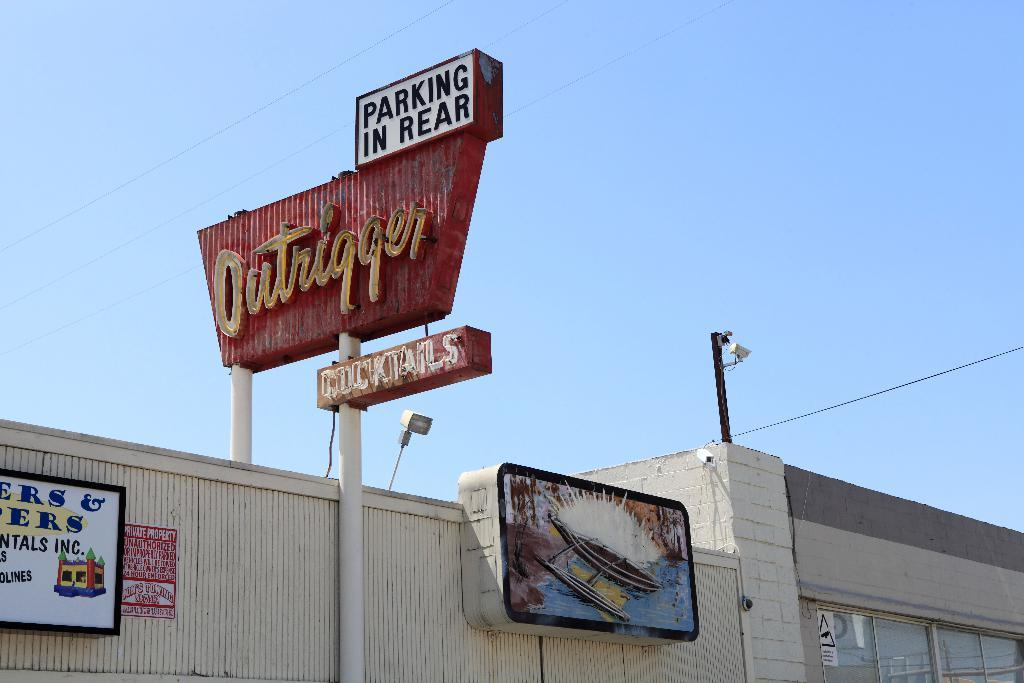<image>
Give a short and clear explanation of the subsequent image. The Outrigger restaurant has a old neon light sign in red and yellow. 